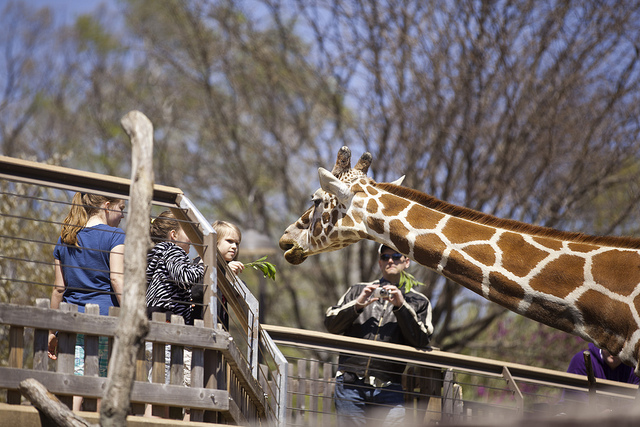Can you tell me more about the setting of this image? Certainly. The image is set in a sunny, outdoor environment where a group of people is interacting with a giraffe. The setting suggests an elevated walkway, possibly within a zoo, designed to bring visitors to eye level with the giraffe to facilitate these educational and engaging encounters. 